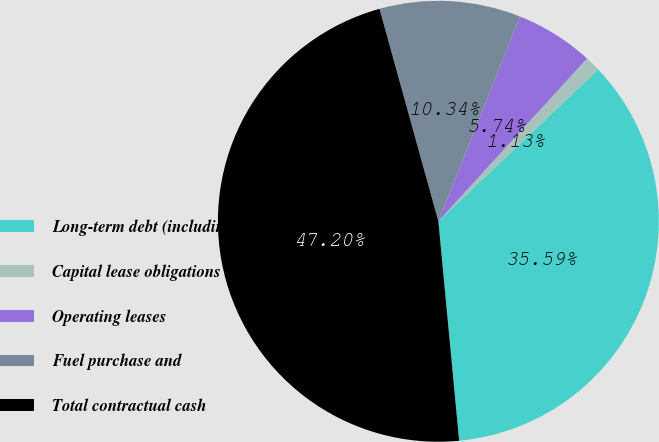Convert chart to OTSL. <chart><loc_0><loc_0><loc_500><loc_500><pie_chart><fcel>Long-term debt (including<fcel>Capital lease obligations<fcel>Operating leases<fcel>Fuel purchase and<fcel>Total contractual cash<nl><fcel>35.59%<fcel>1.13%<fcel>5.74%<fcel>10.34%<fcel>47.2%<nl></chart> 